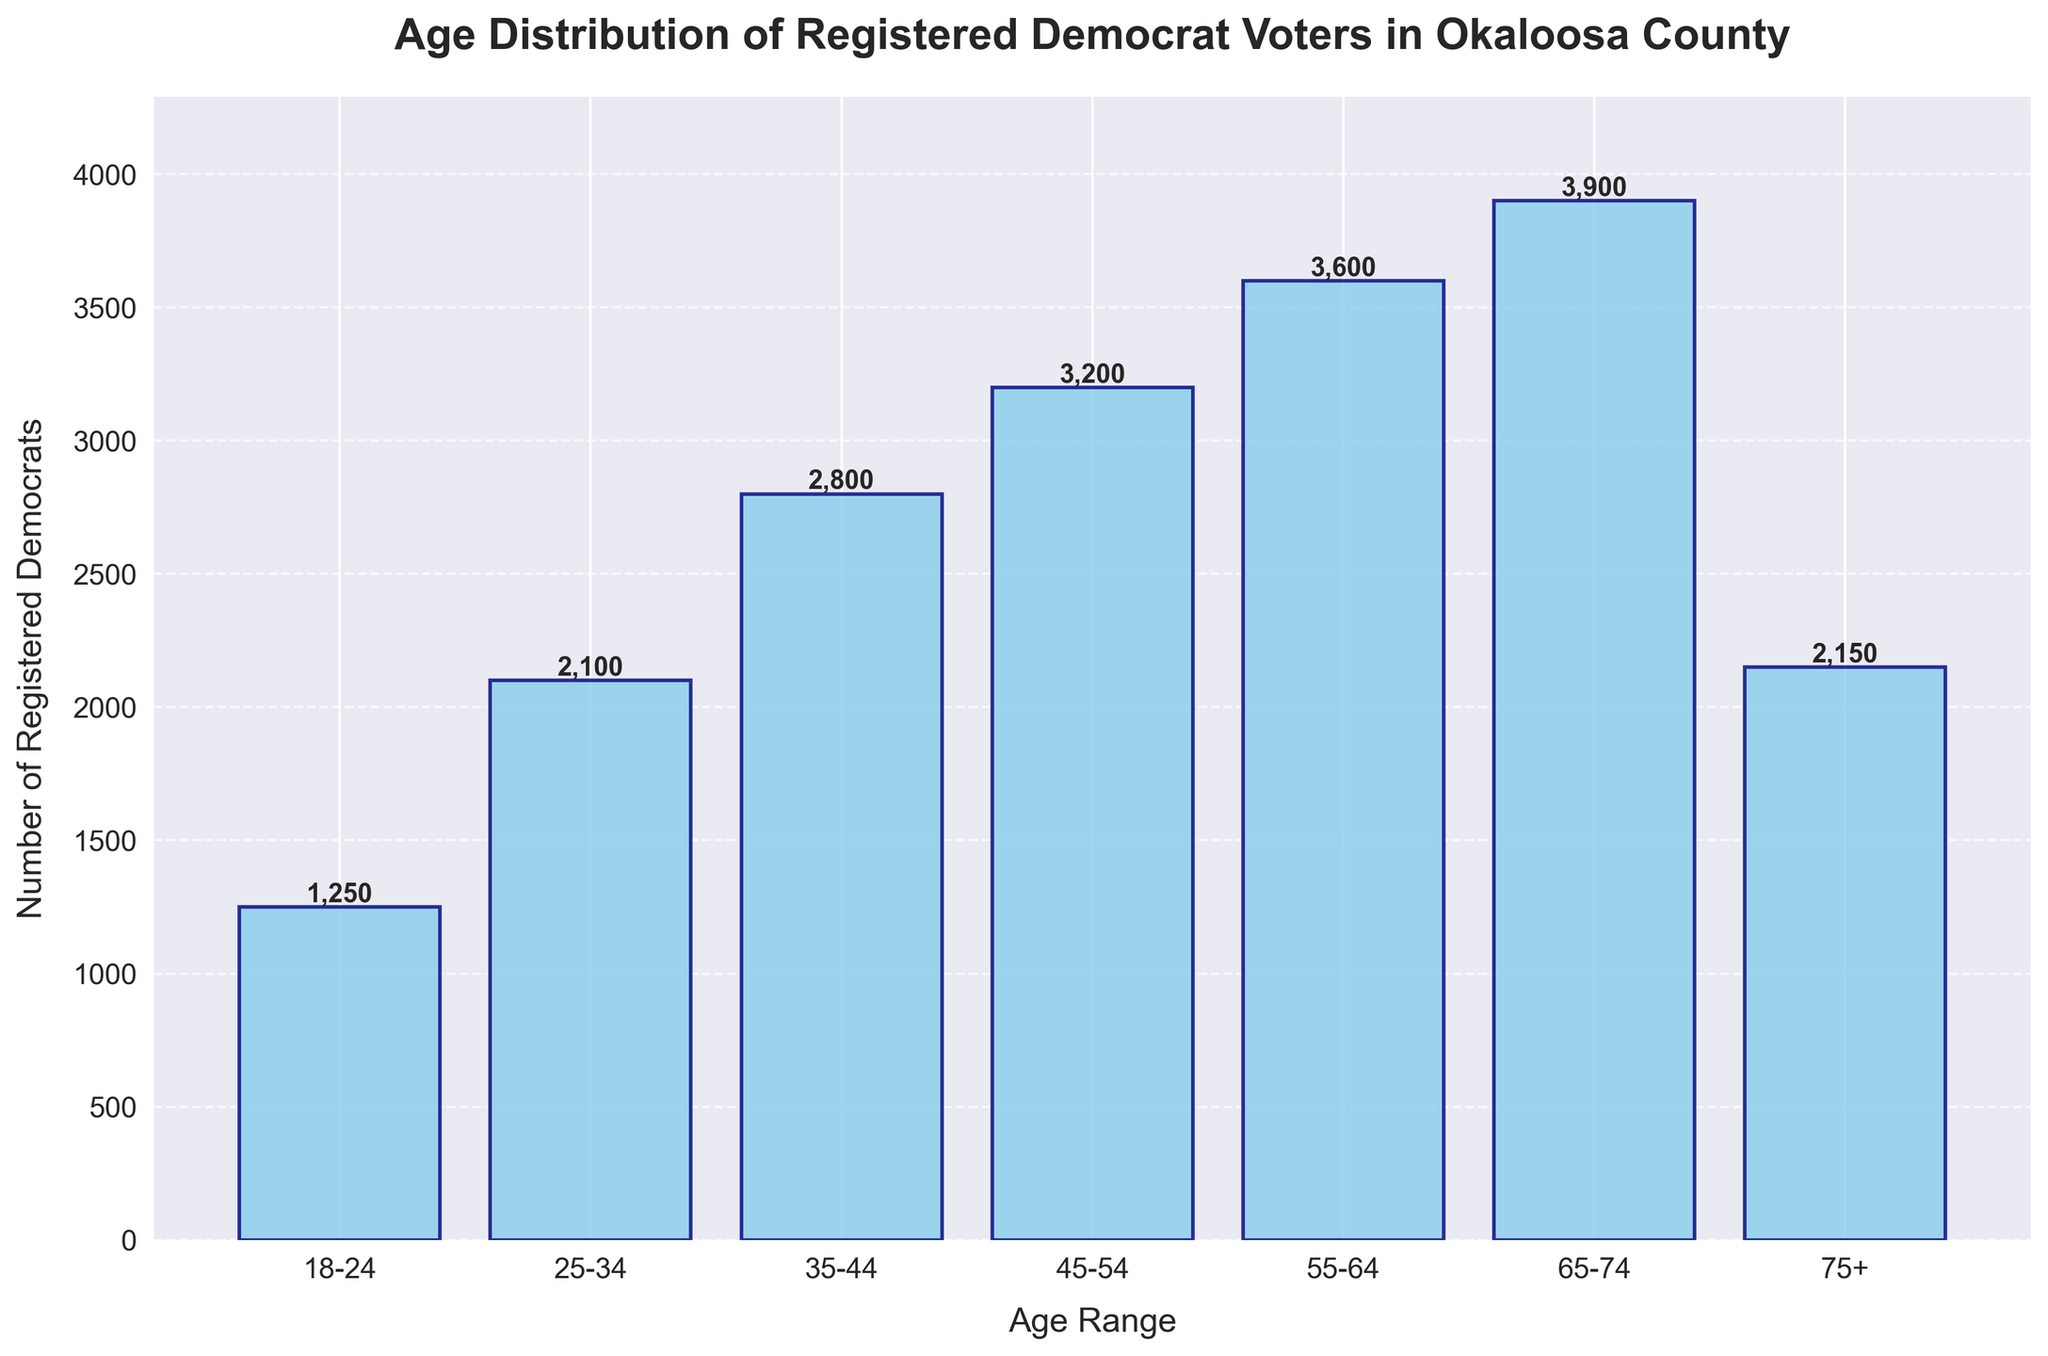What is the title of the histogram? The title is written at the top of the histogram and summarizes what the chart is about.
Answer: Age Distribution of Registered Democrat Voters in Okaloosa County What is the highest number of registered Democrats in any age range? Identify the tallest bar and read its value. The height of the tallest bar represents the highest number of registered Democrats.
Answer: 3900 Which age range has the fewest registered Democrats? Look for the shortest bar among the different age ranges and read its label.
Answer: 18-24 What is the total number of registered Democrats aged 45 and above? Sum the numbers of registered Democrats in the 45-54, 55-64, 65-74, and 75+ age ranges. 3200 + 3600 + 3900 + 2150.
Answer: 12850 Is the number of registered Democrats in the 25-34 age range greater than in the 75+ age range? Compare the heights of the bars corresponding to the 25-34 age range and the 75+ age range. 2100 vs. 2150.
Answer: No What is the average number of registered Democrats across all age ranges? Sum all the values and divide by the number of age ranges. (1250 + 2100 + 2800 + 3200 + 3600 + 3900 + 2150) / 7.
Answer: 2714.29 How many registered Democrats are there in the age ranges of 18-24 and 25-34 combined? Add the numbers of registered Democrats in the 18-24 and 25-34 age ranges. 1250 + 2100.
Answer: 3350 Is the number of registered Democrats in the 55-64 age range more than half of those in the 65-74 age range? Compare the value of the 55-64 age range with half of the 65-74 age range number. 3600 vs. 3900 / 2 (1950).
Answer: Yes 